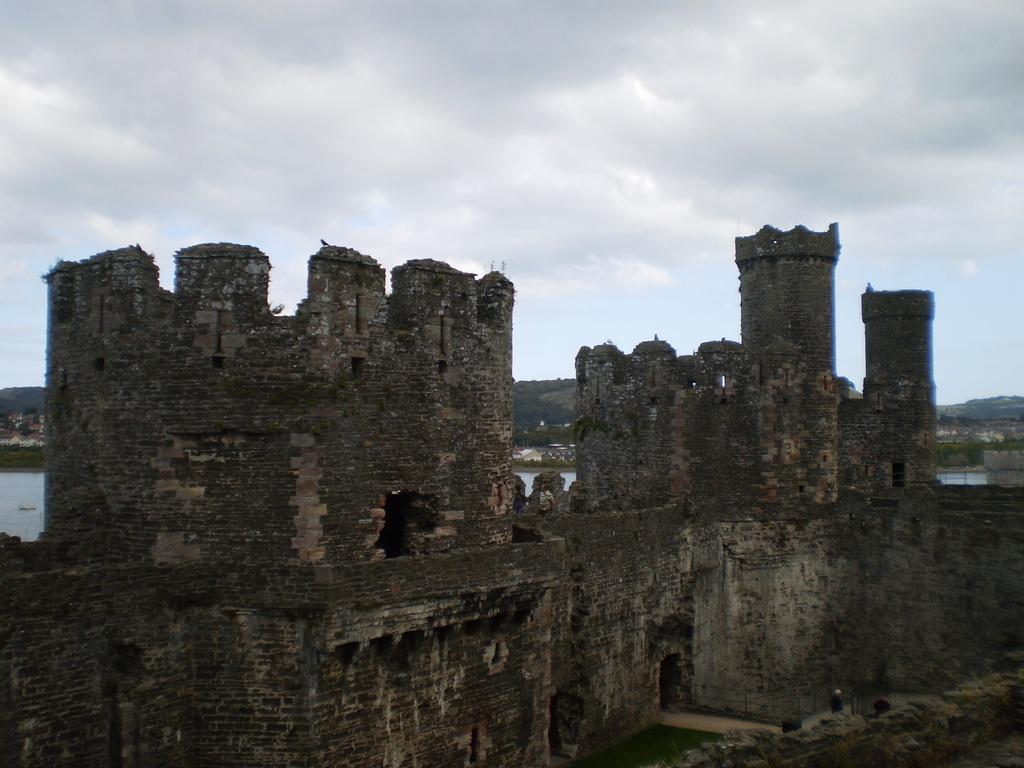What is the main subject in the center of the image? There is an old fort in the center of the image. What can be seen in the background of the image? There are mountains in the background of the image. Is there any water visible in the image? Yes, there is water visible in the image. What type of art can be seen on the walls of the fort in the image? There is no information about art on the walls of the fort in the image. 